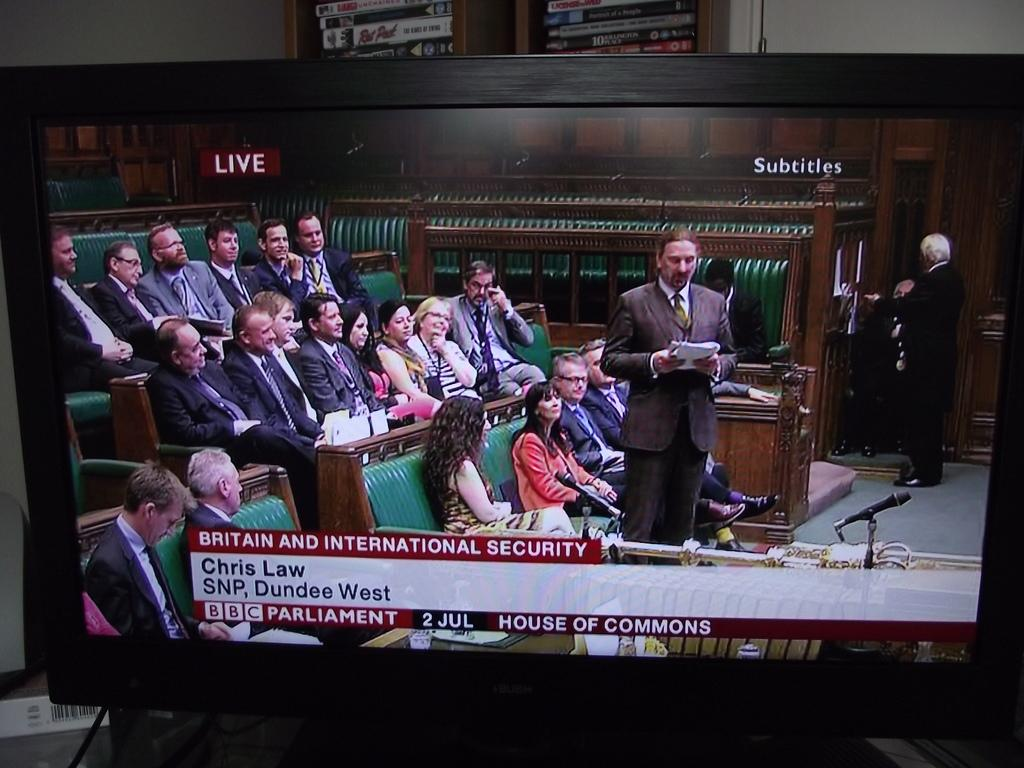Provide a one-sentence caption for the provided image. A tv is tuned into a BBC Parliament discussion on security. 